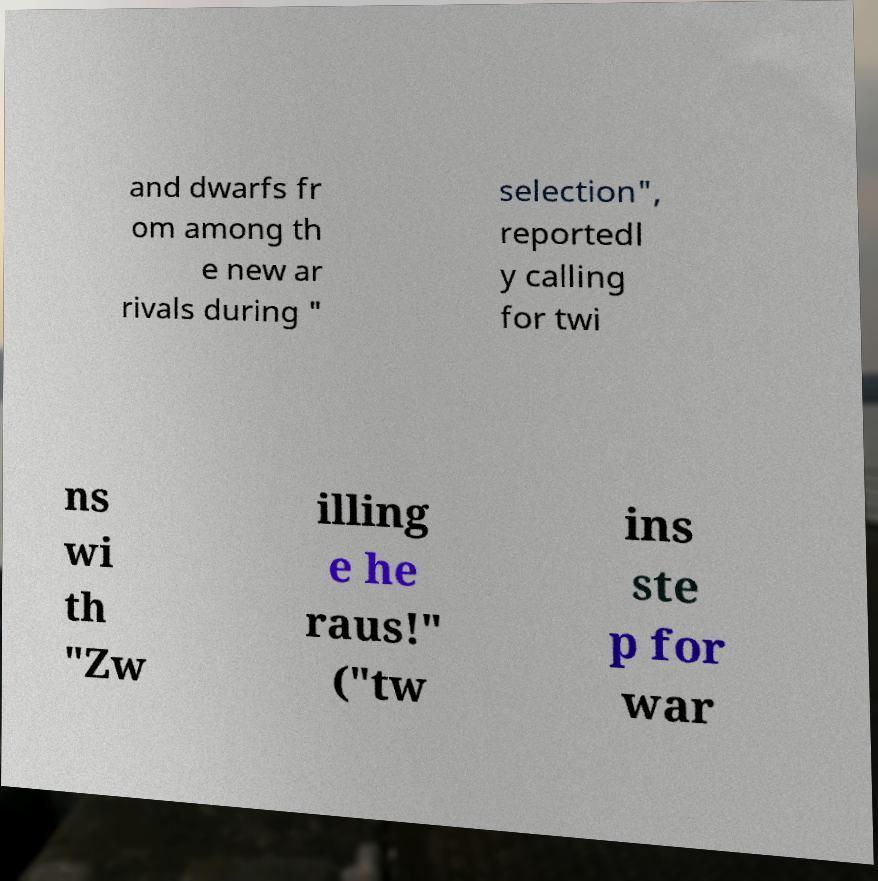For documentation purposes, I need the text within this image transcribed. Could you provide that? and dwarfs fr om among th e new ar rivals during " selection", reportedl y calling for twi ns wi th "Zw illing e he raus!" ("tw ins ste p for war 